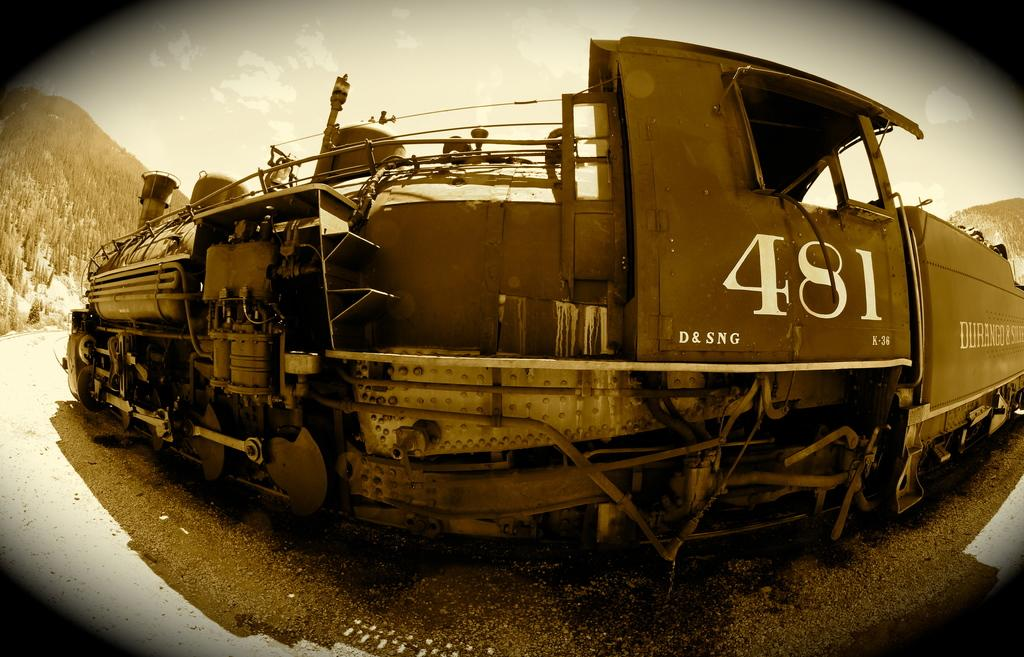<image>
Write a terse but informative summary of the picture. Old fashioned train engine 481 has been photographed in sepia tones with a distorting lens. 